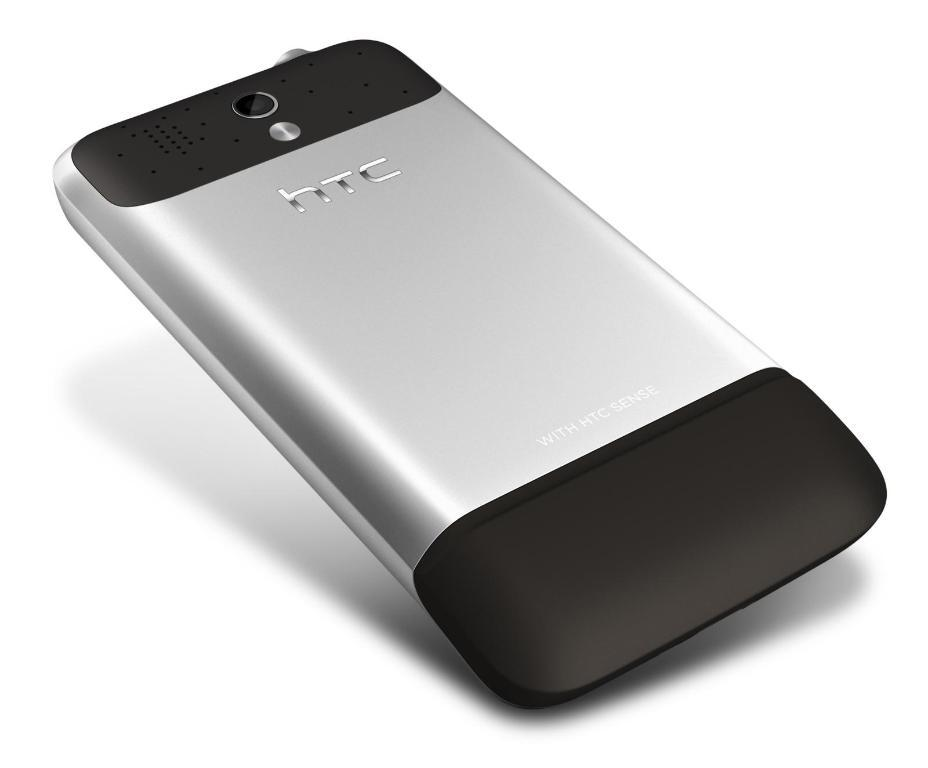Provide a one-sentence caption for the provided image. A silvere and black HTC cell phone on a white background. 